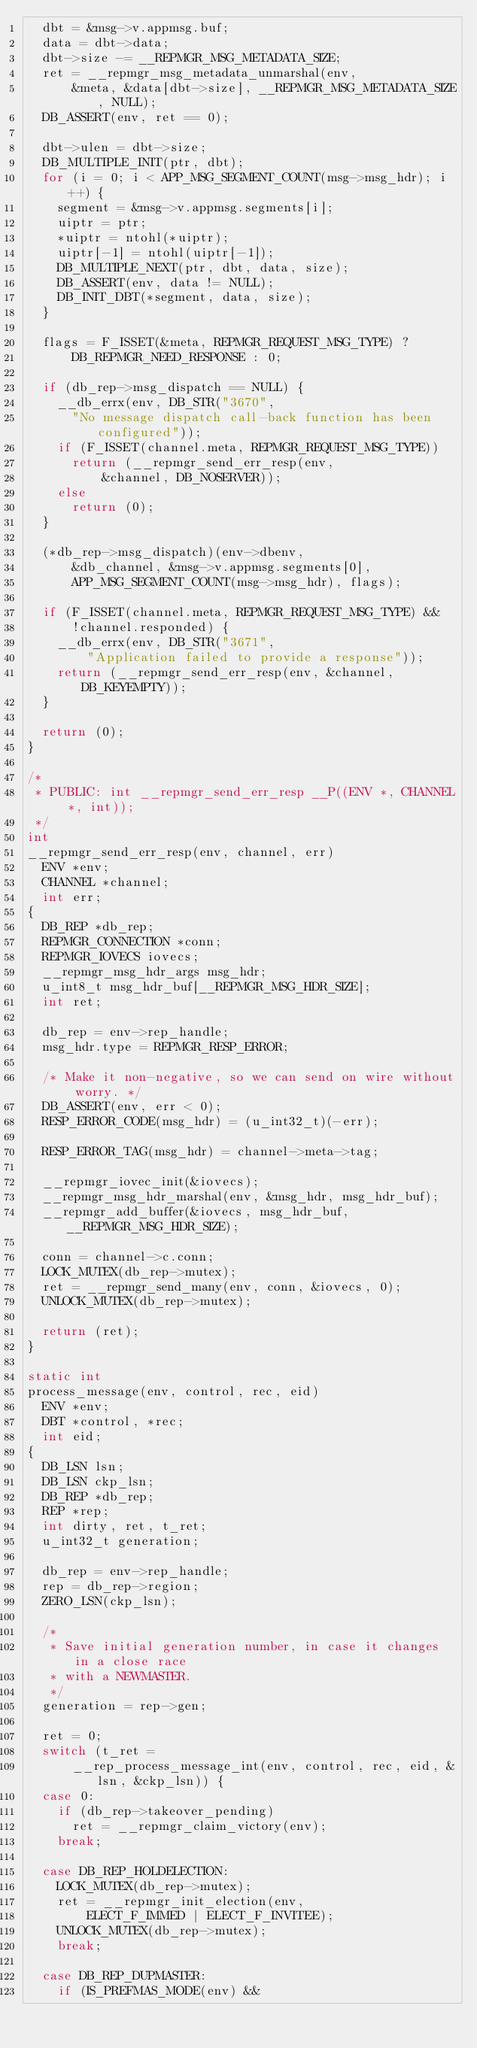<code> <loc_0><loc_0><loc_500><loc_500><_C_>	dbt = &msg->v.appmsg.buf;
	data = dbt->data;
	dbt->size -= __REPMGR_MSG_METADATA_SIZE;
	ret = __repmgr_msg_metadata_unmarshal(env,
	    &meta, &data[dbt->size], __REPMGR_MSG_METADATA_SIZE, NULL);
	DB_ASSERT(env, ret == 0);

	dbt->ulen = dbt->size;
	DB_MULTIPLE_INIT(ptr, dbt);
	for (i = 0; i < APP_MSG_SEGMENT_COUNT(msg->msg_hdr); i++) {
		segment = &msg->v.appmsg.segments[i];
		uiptr = ptr;
		*uiptr = ntohl(*uiptr);
		uiptr[-1] = ntohl(uiptr[-1]);
		DB_MULTIPLE_NEXT(ptr, dbt, data, size);
		DB_ASSERT(env, data != NULL);
		DB_INIT_DBT(*segment, data, size);
	}

	flags = F_ISSET(&meta, REPMGR_REQUEST_MSG_TYPE) ?
	    DB_REPMGR_NEED_RESPONSE : 0;

	if (db_rep->msg_dispatch == NULL) {
		__db_errx(env, DB_STR("3670",
	    "No message dispatch call-back function has been configured"));
		if (F_ISSET(channel.meta, REPMGR_REQUEST_MSG_TYPE))
			return (__repmgr_send_err_resp(env,
			    &channel, DB_NOSERVER));
		else
			return (0);
	}

	(*db_rep->msg_dispatch)(env->dbenv,
	    &db_channel, &msg->v.appmsg.segments[0],
	    APP_MSG_SEGMENT_COUNT(msg->msg_hdr), flags);

	if (F_ISSET(channel.meta, REPMGR_REQUEST_MSG_TYPE) &&
	    !channel.responded) {
		__db_errx(env, DB_STR("3671",
		    "Application failed to provide a response"));
		return (__repmgr_send_err_resp(env, &channel, DB_KEYEMPTY));
	}

	return (0);
}

/*
 * PUBLIC: int __repmgr_send_err_resp __P((ENV *, CHANNEL *, int));
 */
int
__repmgr_send_err_resp(env, channel, err)
	ENV *env;
	CHANNEL *channel;
	int err;
{
	DB_REP *db_rep;
	REPMGR_CONNECTION *conn;
	REPMGR_IOVECS iovecs;
	__repmgr_msg_hdr_args msg_hdr;
	u_int8_t msg_hdr_buf[__REPMGR_MSG_HDR_SIZE];
	int ret;

	db_rep = env->rep_handle;
	msg_hdr.type = REPMGR_RESP_ERROR;

	/* Make it non-negative, so we can send on wire without worry. */
	DB_ASSERT(env, err < 0);
	RESP_ERROR_CODE(msg_hdr) = (u_int32_t)(-err);

	RESP_ERROR_TAG(msg_hdr) = channel->meta->tag;

	__repmgr_iovec_init(&iovecs);
	__repmgr_msg_hdr_marshal(env, &msg_hdr, msg_hdr_buf);
	__repmgr_add_buffer(&iovecs, msg_hdr_buf, __REPMGR_MSG_HDR_SIZE);

	conn = channel->c.conn;
	LOCK_MUTEX(db_rep->mutex);
	ret = __repmgr_send_many(env, conn, &iovecs, 0);
	UNLOCK_MUTEX(db_rep->mutex);

	return (ret);
}

static int
process_message(env, control, rec, eid)
	ENV *env;
	DBT *control, *rec;
	int eid;
{
	DB_LSN lsn;
	DB_LSN ckp_lsn;
	DB_REP *db_rep;
	REP *rep;
	int dirty, ret, t_ret;
	u_int32_t generation;

	db_rep = env->rep_handle;
	rep = db_rep->region;
	ZERO_LSN(ckp_lsn);

	/*
	 * Save initial generation number, in case it changes in a close race
	 * with a NEWMASTER.
	 */
	generation = rep->gen;

	ret = 0;
	switch (t_ret =
	    __rep_process_message_int(env, control, rec, eid, &lsn, &ckp_lsn)) {
	case 0:
		if (db_rep->takeover_pending)
			ret = __repmgr_claim_victory(env);
		break;

	case DB_REP_HOLDELECTION:
		LOCK_MUTEX(db_rep->mutex);
		ret = __repmgr_init_election(env,
		    ELECT_F_IMMED | ELECT_F_INVITEE);
		UNLOCK_MUTEX(db_rep->mutex);
		break;

	case DB_REP_DUPMASTER:
		if (IS_PREFMAS_MODE(env) &&</code> 